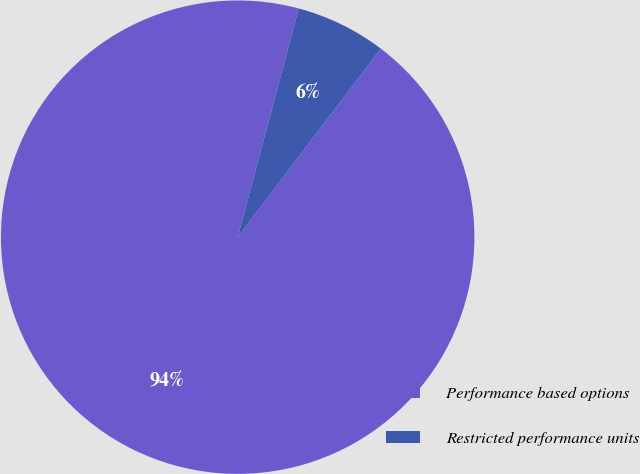Convert chart to OTSL. <chart><loc_0><loc_0><loc_500><loc_500><pie_chart><fcel>Performance based options<fcel>Restricted performance units<nl><fcel>93.82%<fcel>6.18%<nl></chart> 